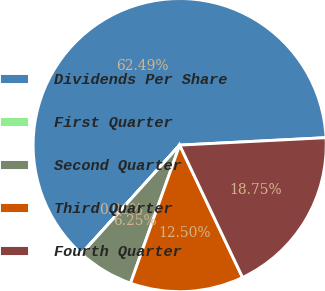Convert chart to OTSL. <chart><loc_0><loc_0><loc_500><loc_500><pie_chart><fcel>Dividends Per Share<fcel>First Quarter<fcel>Second Quarter<fcel>Third Quarter<fcel>Fourth Quarter<nl><fcel>62.49%<fcel>0.01%<fcel>6.25%<fcel>12.5%<fcel>18.75%<nl></chart> 